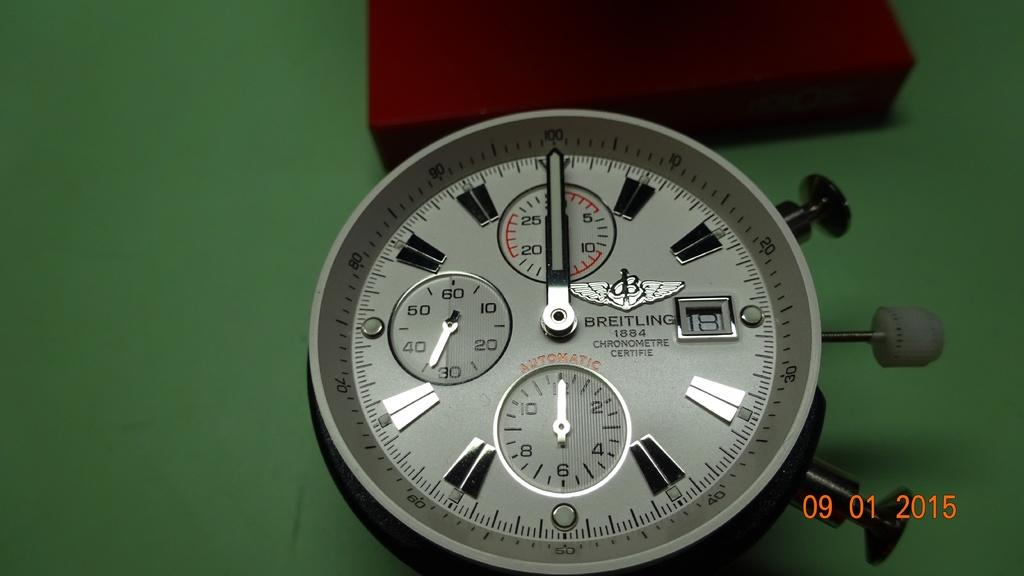Provide a one-sentence caption for the provided image. A watch is branded Breitling 1884 and features an automatic chronometre. 